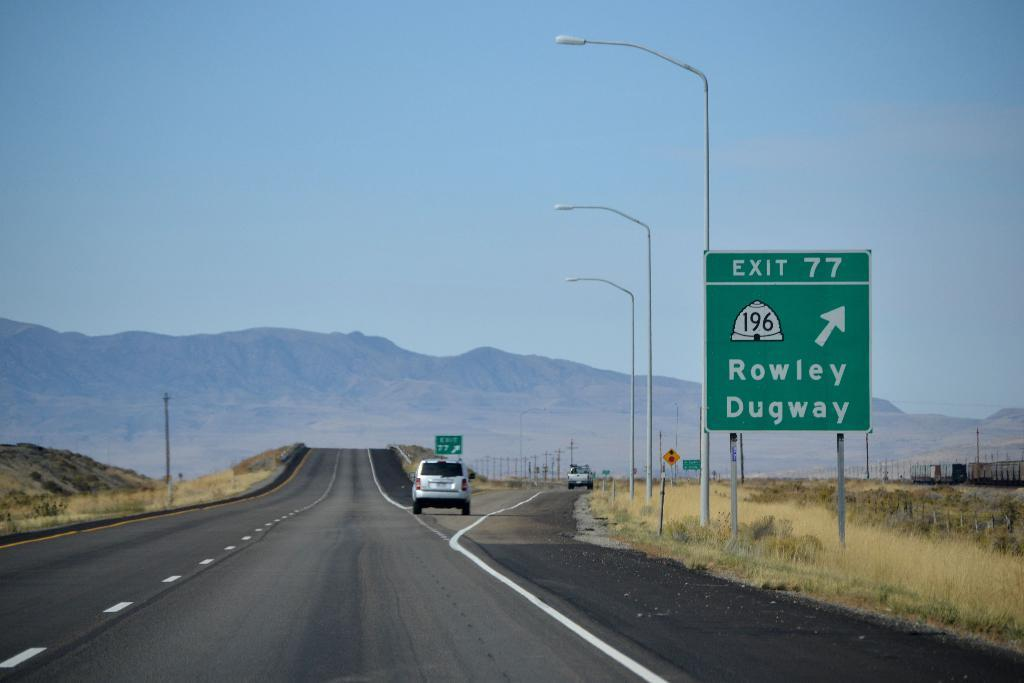<image>
Provide a brief description of the given image. a sign with the name exit 77 at the top of it 